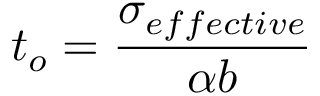<formula> <loc_0><loc_0><loc_500><loc_500>t _ { o } = \frac { \sigma _ { e f f e c t i v e } } { \alpha b }</formula> 